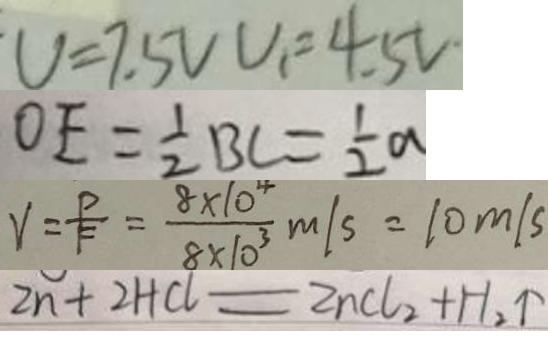<formula> <loc_0><loc_0><loc_500><loc_500>V = 7 . 5 V V _ { 1 } = 4 . 5 V 
 O E = \frac { 1 } { 2 } B C = \frac { 1 } { 2 } a 
 V = \frac { P } { F } = \frac { 8 \times 1 0 ^ { 4 } } { 8 \times 1 0 ^ { 3 } } m / s = 1 0 m / s 
 Z n + 2 H C l = Z n C l _ { 2 } + H _ { 2 } \uparrow</formula> 